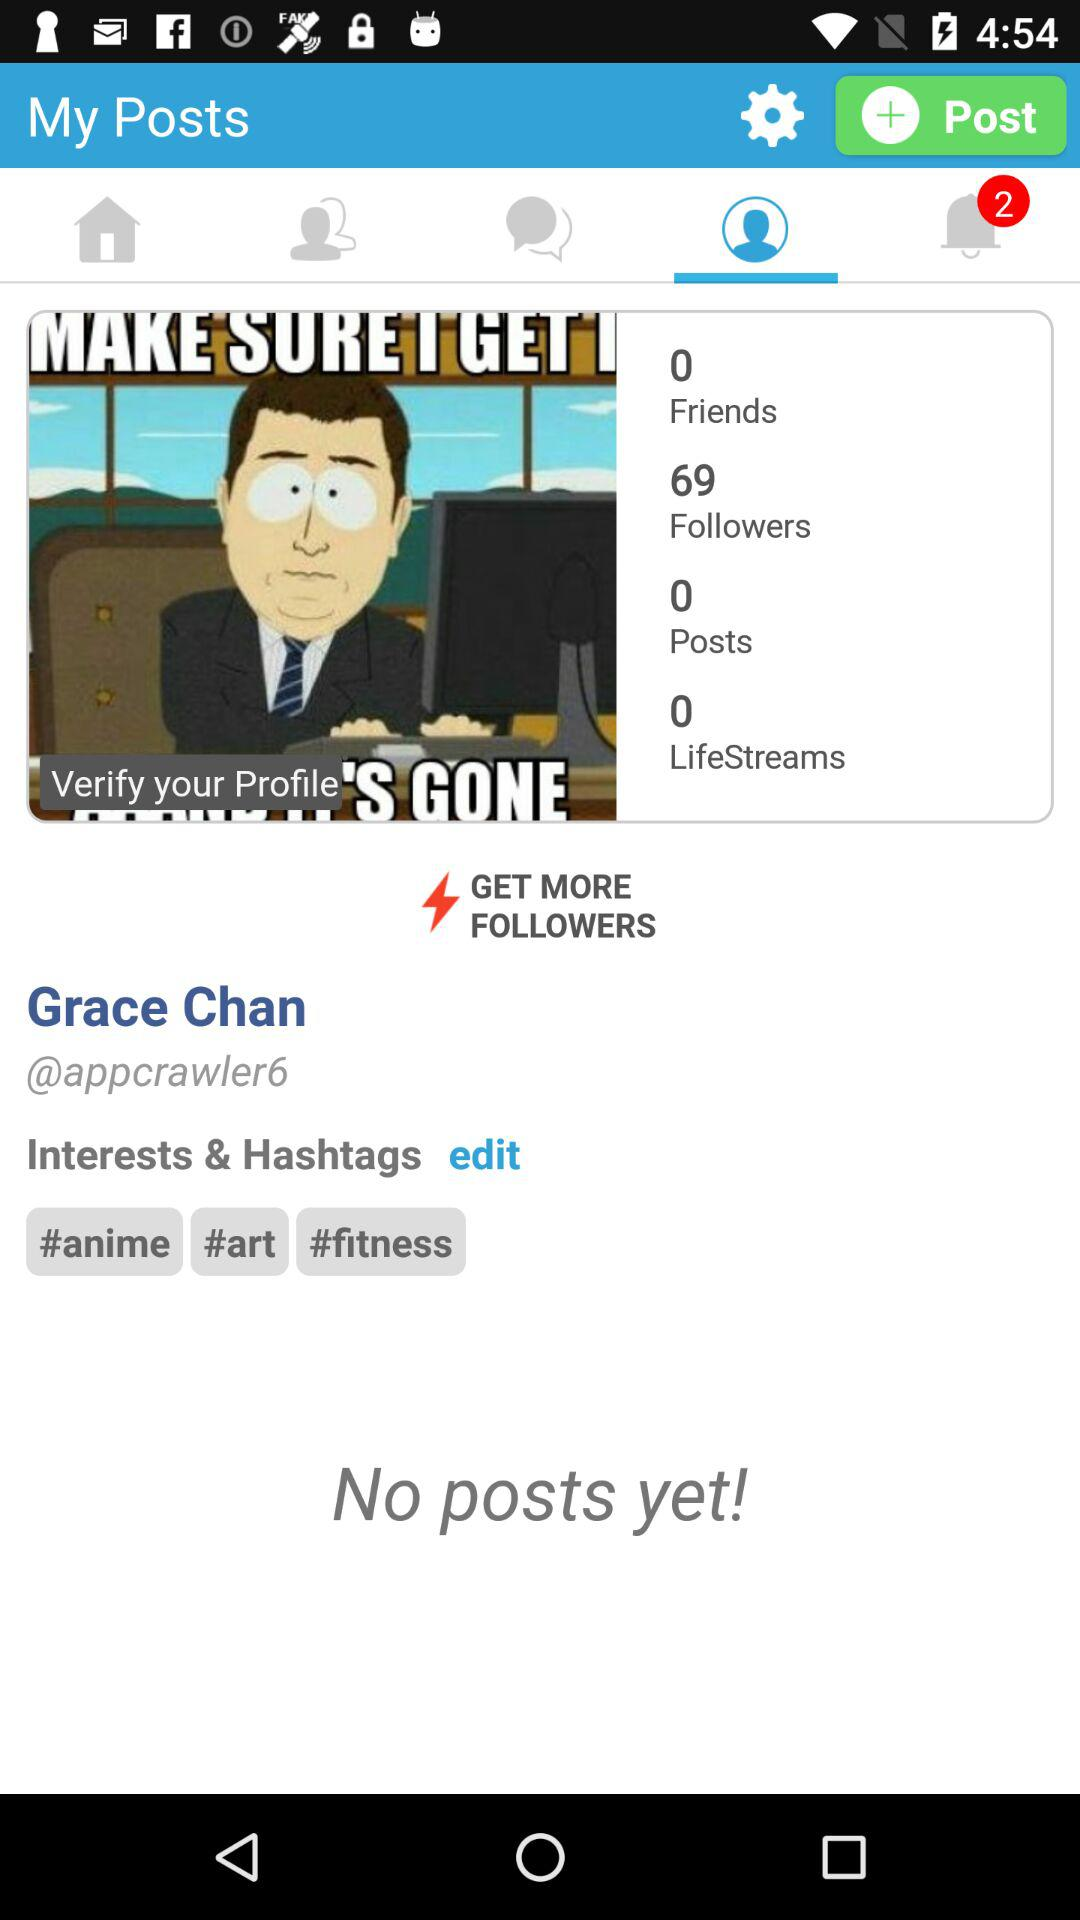How many followers are there? There are 69 followers. 